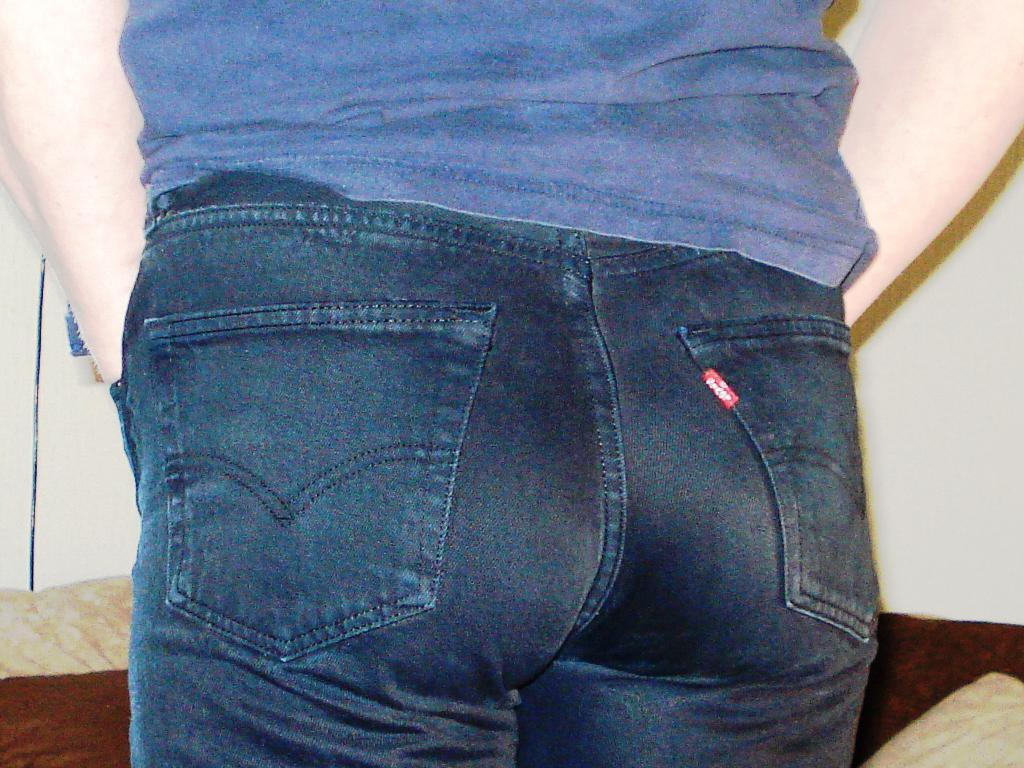Who or what is present in the image? There is a person in the image. What is the person doing in the image? The person is standing on a path. What is in front of the person? There is a wall in front of the person. What type of iron is the person using to press their clothes in the image? There is no iron present in the image; the person is standing on a path with a wall in front of them. 